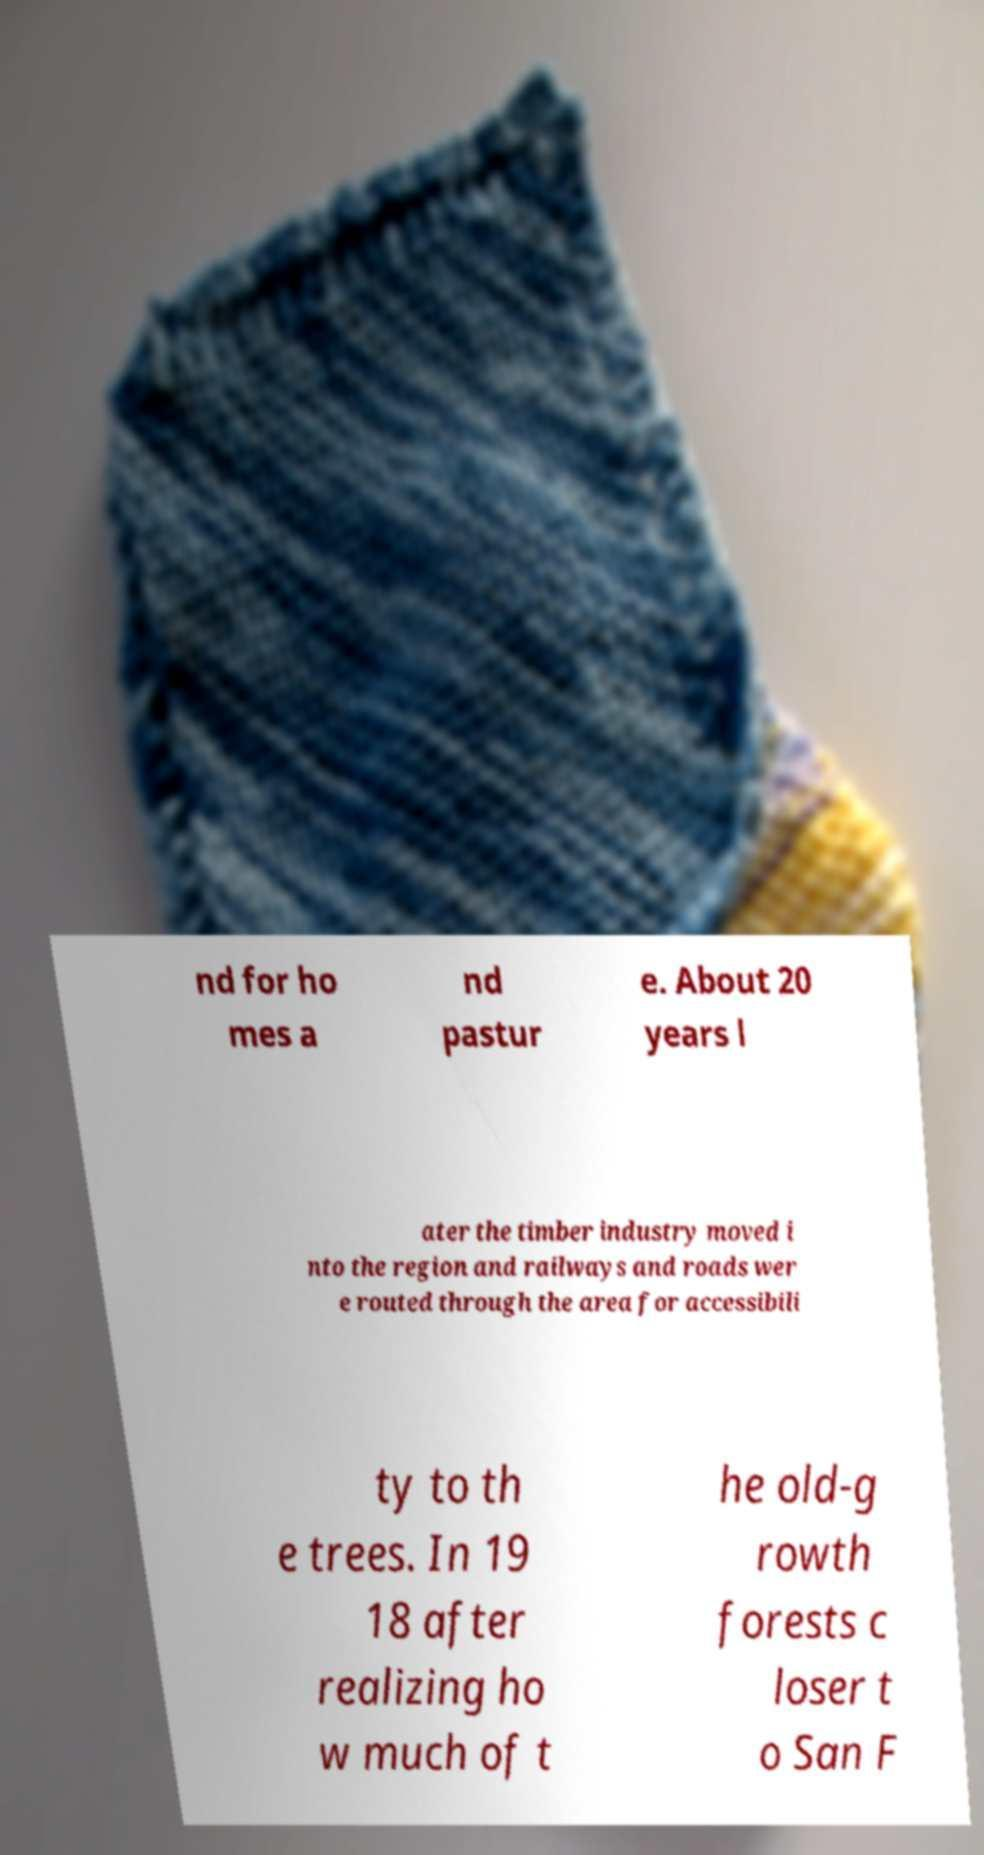Could you assist in decoding the text presented in this image and type it out clearly? nd for ho mes a nd pastur e. About 20 years l ater the timber industry moved i nto the region and railways and roads wer e routed through the area for accessibili ty to th e trees. In 19 18 after realizing ho w much of t he old-g rowth forests c loser t o San F 